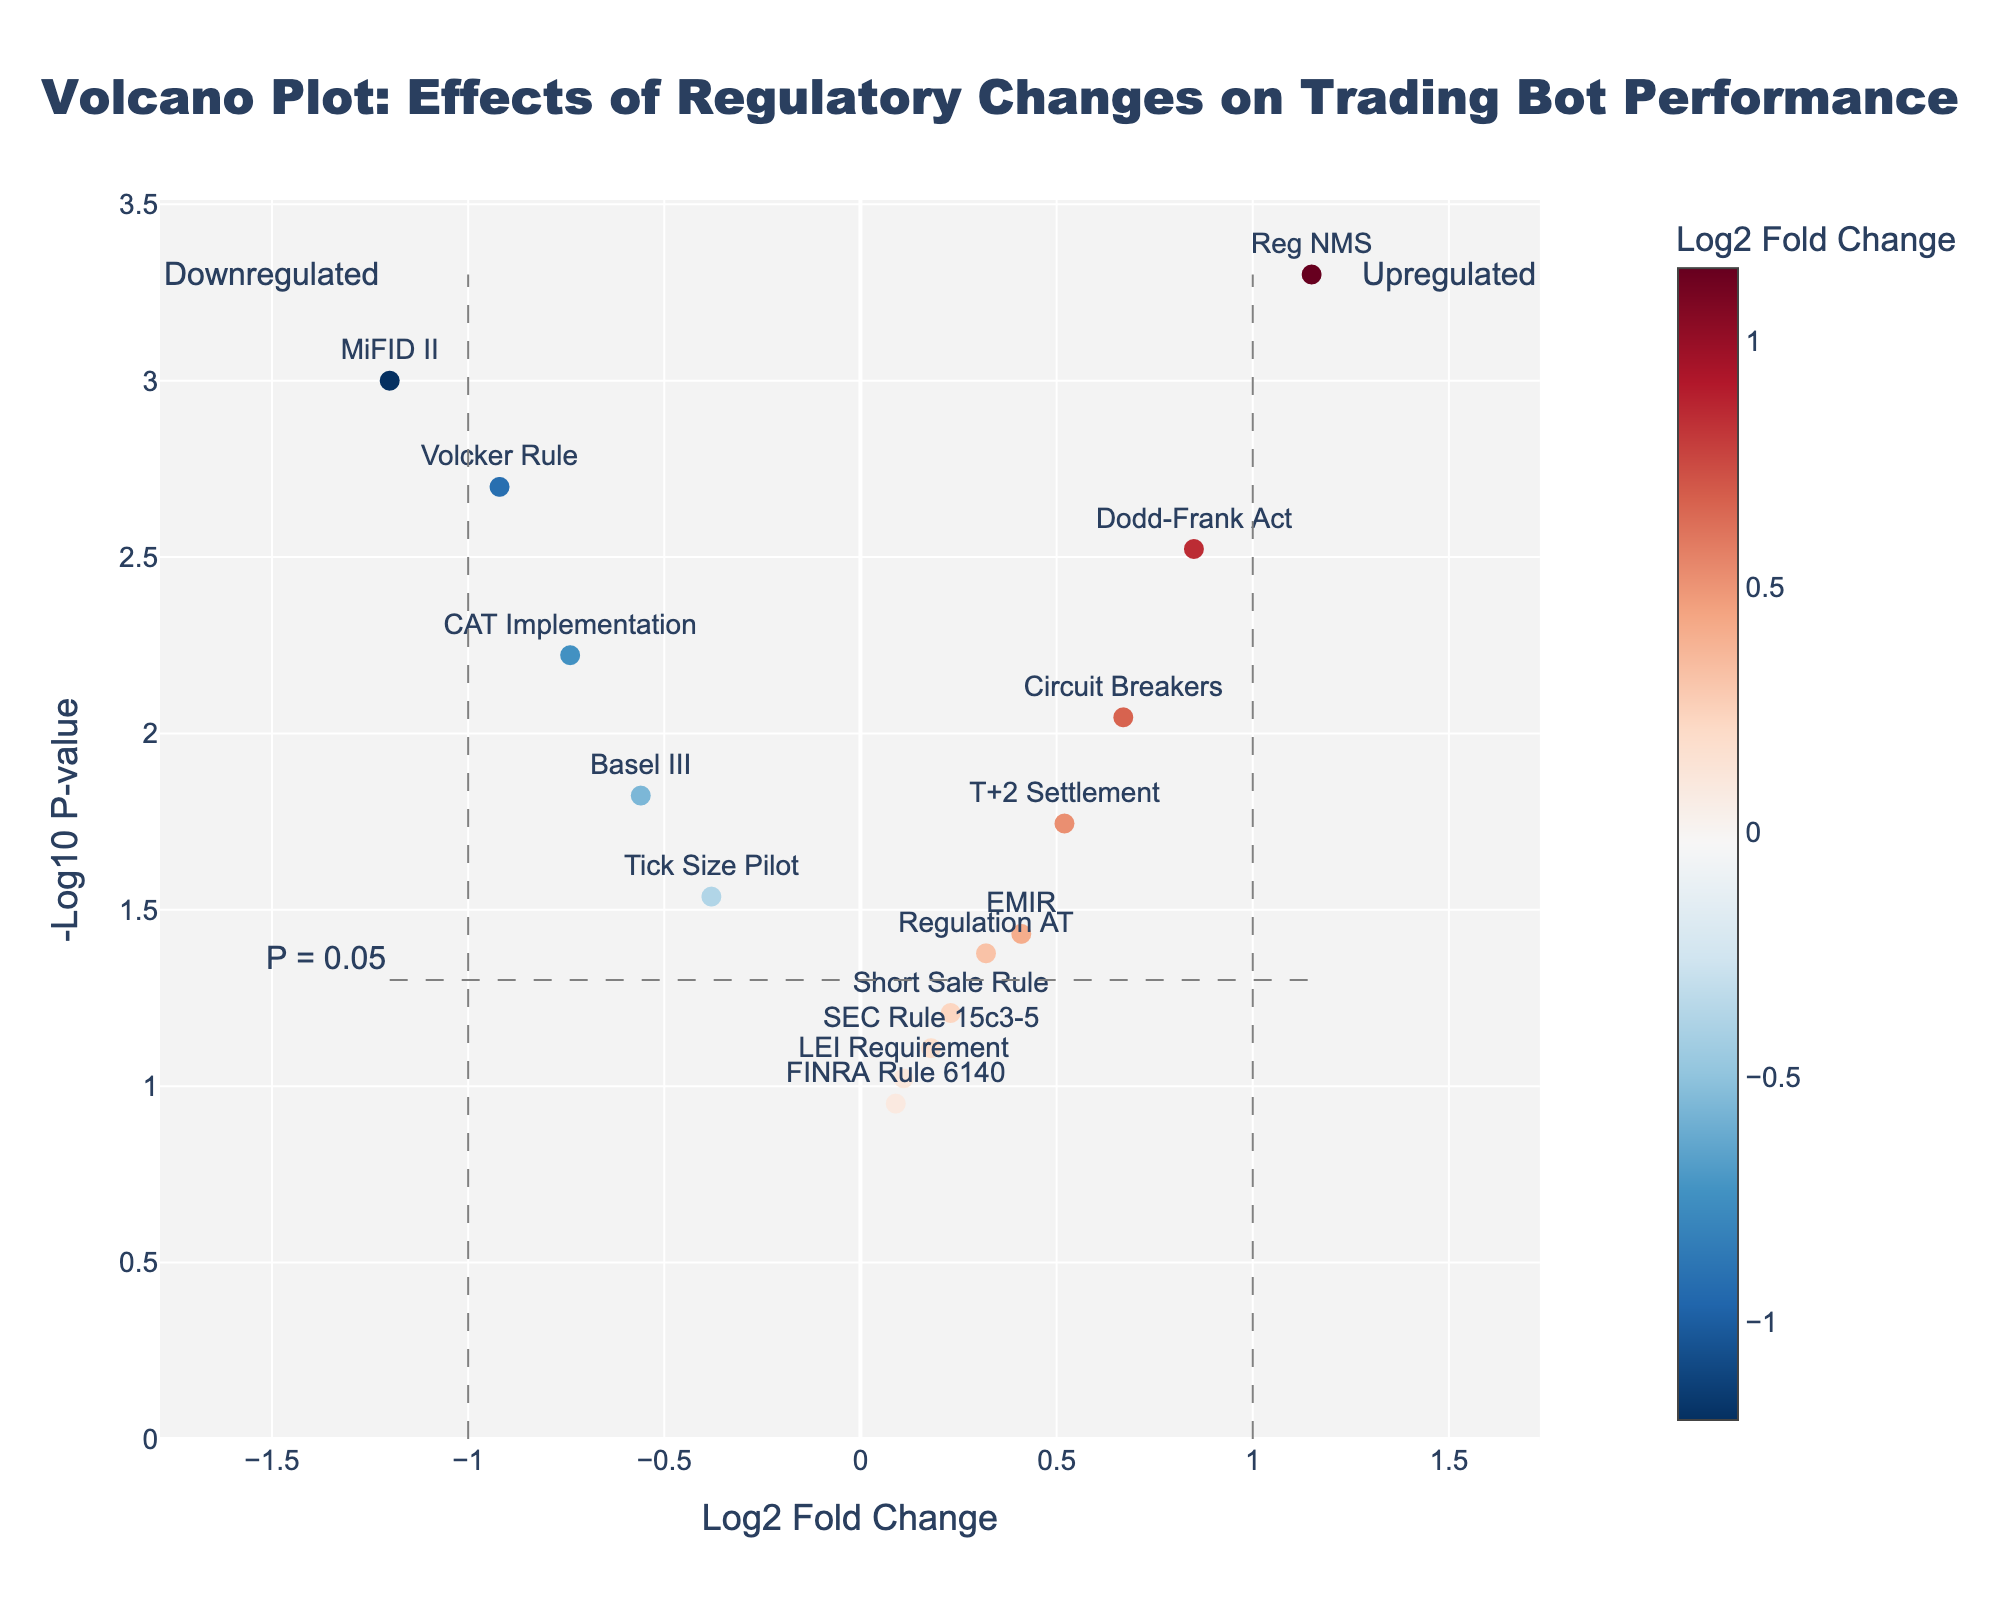Which regulatory changes have significant impacts on trading bot performance, and are they positive or negative? To determine significance, look for points above the horizontal "P = 0.05" line. Points left of the vertical `log2 fold change=-1` line are negative impacts (downregulated) and points right of the vertical `log2 fold change=1` line are positive (upregulated). Dodd-Frank Act, MiFID II, Basel III, Volcker Rule, Circuit Breakers, Tick Size Pilot, Reg NMS, and CAT Implementation are significant. Among these, MiFID II, Basel III, Volcker Rule, Tick Size Pilot, and CAT Implementation are negative, while the rest are positive.
Answer: Eight changes are significant; five negative (MiFID II, Basel III, Volcker Rule, Tick Size Pilot, CAT Implementation) and three positive (Dodd-Frank Act, Circuit Breakers, Reg NMS) What is the most statistically significant regulatory change affecting trading bot performance? This requires identifying the data point with the highest `-Log10 P-value` since a higher −log10(P-value) denotes greater significance. The highest point represents Reg NMS, with a `-Log10 P-value` close to 3.3.
Answer: Reg NMS Which regulatory changes show moderate but detectable impacts on trading bot performance? Moderate impacts are identified as points that fall between the fold change thresholds (`-1 < log2 fold change < 1`) yet lie above the `P = 0.05` line. Regulation AT, EMIR, T+2 Settlement fall into this category.
Answer: Regulation AT, EMIR, T+2 Settlement How does the effect of MiFID II compare to that of Reg NMS on trading bot performance? Compare their positions: MiFID II is significantly downregulated (log2 fold change = -1.2), while Reg NMS is significantly upregulated (log2 fold change = 1.15). This indicates MiFID II negatively impacts performance, whereas Reg NMS positively impacts performance.
Answer: MiFID II has a negative impact; Reg NMS has a positive impact Which regulatory change has the smallest significant positive impact on trading bot performance? Focus on significant points (above the `P = 0.05` line) with a positive `log2 fold change`. The smallest significant positive point is Dodd-Frank Act, with a `log2 fold change` of 0.85.
Answer: Dodd-Frank Act How many regulatory changes have no significant effect on trading bot performance? Look for points below the `P = 0.05` line, regardless of their `log2 fold change`. There are four such points: SEC Rule 15c3-5, Short Sale Rule, FINRA Rule 6140, and LEI Requirement.
Answer: Four regulatory changes How is the -Log10 P-value for the Volcker Rule compared to T+2 Settlement? Identify their `-Log10 P-values` and compare them; Volcker Rule has a higher value (around 2.7) than T+2 Settlement (around 1.74).
Answer: The Volcker Rule has a higher -Log10 P-value What general trend can you observe from the color of the points? Observe the color gradient representing `log2 fold changes`; colors towards blue indicate upregulation, while red indicates downregulation. Most negative impacts are red/maroon, and most positive impacts are blue/light blue, indicating a balance in the impact types.
Answer: Blue indicates upregulation; red indicates downregulation Are there any regulatory changes closer to the `fold change` thresholds but not meeting significance? Which ones are they? Look for points near the vertical lines (`log2 fold changes=±1`) but below the `P = 0.05` line. SEC Rule 15c3-5 (log2 fold change=0.18) and Short Sale Rule (log2 fold change=0.23) are below threshold yet near the boundary, thus not significant.
Answer: SEC Rule 15c3-5, Short Sale Rule 